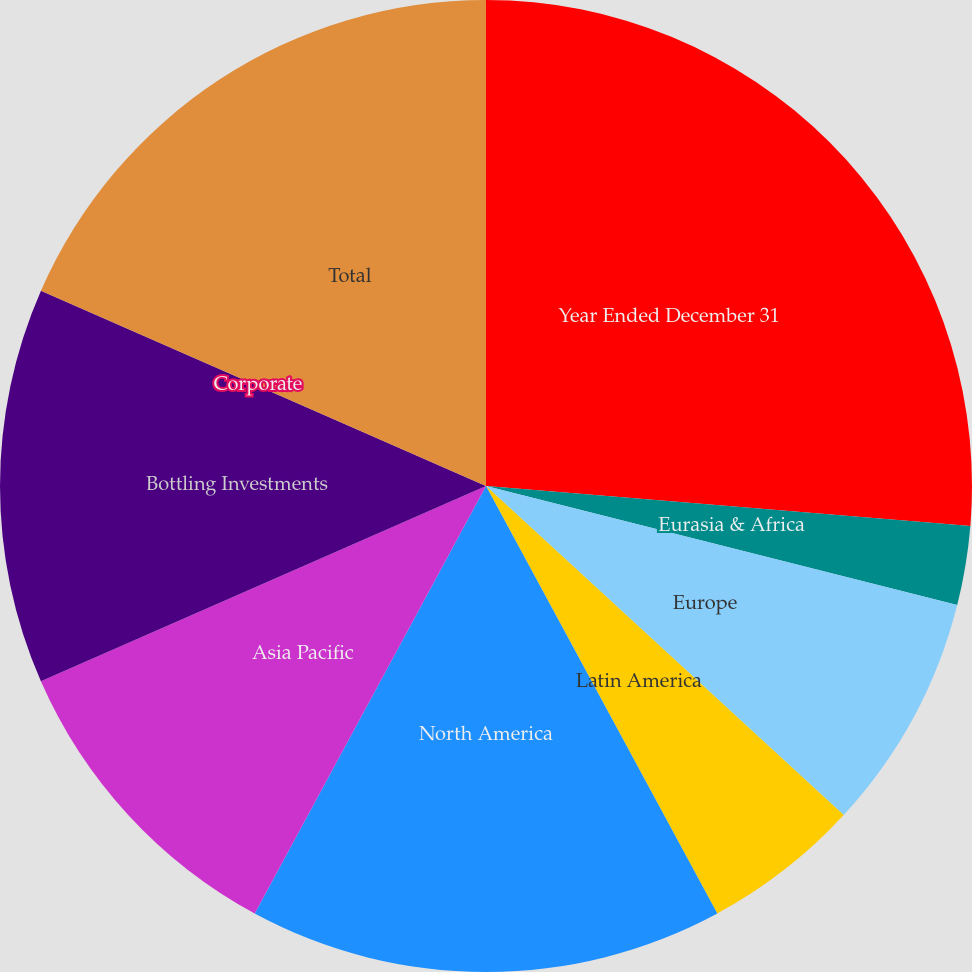<chart> <loc_0><loc_0><loc_500><loc_500><pie_chart><fcel>Year Ended December 31<fcel>Eurasia & Africa<fcel>Europe<fcel>Latin America<fcel>North America<fcel>Asia Pacific<fcel>Bottling Investments<fcel>Corporate<fcel>Total<nl><fcel>26.31%<fcel>2.63%<fcel>7.9%<fcel>5.27%<fcel>15.79%<fcel>10.53%<fcel>13.16%<fcel>0.0%<fcel>18.42%<nl></chart> 